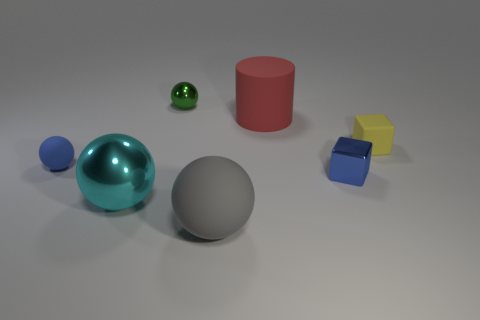Subtract all large cyan metal balls. How many balls are left? 3 Add 3 large red cubes. How many objects exist? 10 Subtract all blue blocks. How many blocks are left? 1 Subtract all balls. How many objects are left? 3 Subtract 2 spheres. How many spheres are left? 2 Subtract all purple cylinders. How many green spheres are left? 1 Subtract all green things. Subtract all large red objects. How many objects are left? 5 Add 6 blue matte things. How many blue matte things are left? 7 Add 6 big green metallic objects. How many big green metallic objects exist? 6 Subtract 0 gray cylinders. How many objects are left? 7 